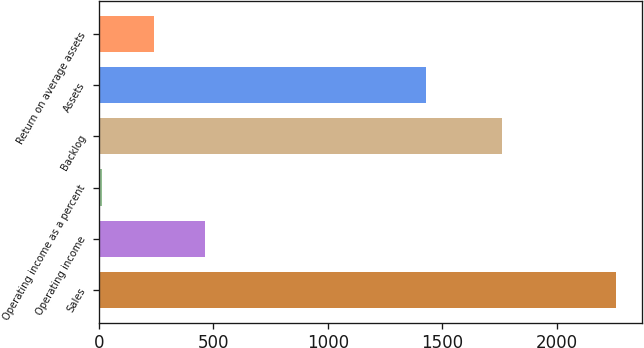<chart> <loc_0><loc_0><loc_500><loc_500><bar_chart><fcel>Sales<fcel>Operating income<fcel>Operating income as a percent<fcel>Backlog<fcel>Assets<fcel>Return on average assets<nl><fcel>2260<fcel>463.92<fcel>14.9<fcel>1762<fcel>1431<fcel>239.41<nl></chart> 